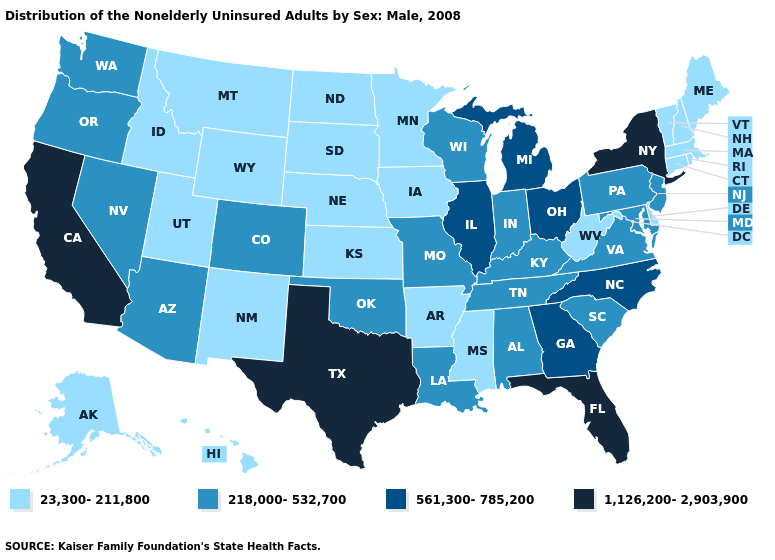Name the states that have a value in the range 218,000-532,700?
Be succinct. Alabama, Arizona, Colorado, Indiana, Kentucky, Louisiana, Maryland, Missouri, Nevada, New Jersey, Oklahoma, Oregon, Pennsylvania, South Carolina, Tennessee, Virginia, Washington, Wisconsin. What is the value of Oklahoma?
Give a very brief answer. 218,000-532,700. Which states have the lowest value in the MidWest?
Short answer required. Iowa, Kansas, Minnesota, Nebraska, North Dakota, South Dakota. Does Wisconsin have a lower value than Ohio?
Keep it brief. Yes. What is the value of Iowa?
Concise answer only. 23,300-211,800. How many symbols are there in the legend?
Short answer required. 4. What is the highest value in states that border Missouri?
Concise answer only. 561,300-785,200. Among the states that border Louisiana , which have the highest value?
Keep it brief. Texas. Name the states that have a value in the range 1,126,200-2,903,900?
Concise answer only. California, Florida, New York, Texas. Does Connecticut have the lowest value in the Northeast?
Quick response, please. Yes. Which states have the highest value in the USA?
Answer briefly. California, Florida, New York, Texas. Does Georgia have the lowest value in the South?
Write a very short answer. No. What is the value of North Dakota?
Keep it brief. 23,300-211,800. Does New Jersey have the lowest value in the Northeast?
Concise answer only. No. 